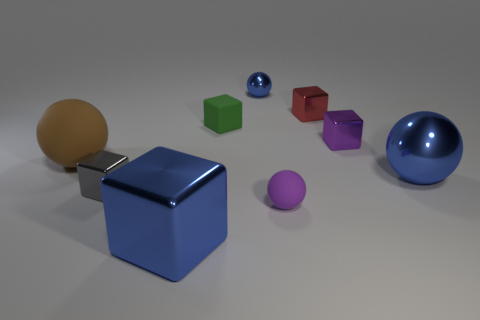There is a block that is the same color as the small matte sphere; what is its material?
Offer a terse response. Metal. The large sphere to the left of the blue ball left of the cube that is behind the green thing is what color?
Your answer should be compact. Brown. How many tiny objects are blue matte cylinders or brown matte objects?
Ensure brevity in your answer.  0. Are there the same number of brown objects that are in front of the big matte thing and blue metallic cylinders?
Keep it short and to the point. Yes. Are there any small matte objects in front of the small green thing?
Provide a short and direct response. Yes. What number of metallic objects are either tiny gray things or big brown balls?
Your answer should be very brief. 1. What number of rubber balls are in front of the large blue cube?
Your answer should be compact. 0. Is there a purple matte ball of the same size as the blue metallic block?
Provide a short and direct response. No. Is there a large metallic block that has the same color as the large metallic sphere?
Make the answer very short. Yes. How many things are the same color as the large metal block?
Ensure brevity in your answer.  2. 